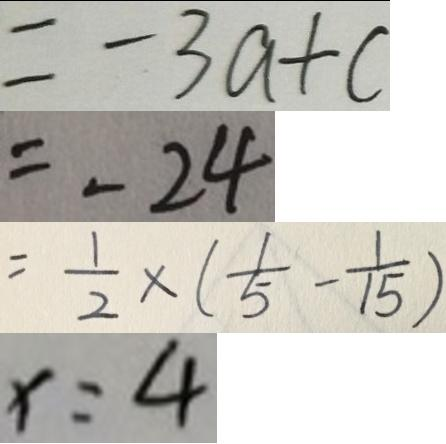Convert formula to latex. <formula><loc_0><loc_0><loc_500><loc_500>= - 3 a + c 
 = - 2 4 
 = \frac { 1 } { 2 } \times ( \frac { 1 } { 5 } - \frac { 1 } { 1 5 } ) 
 x = 4</formula> 